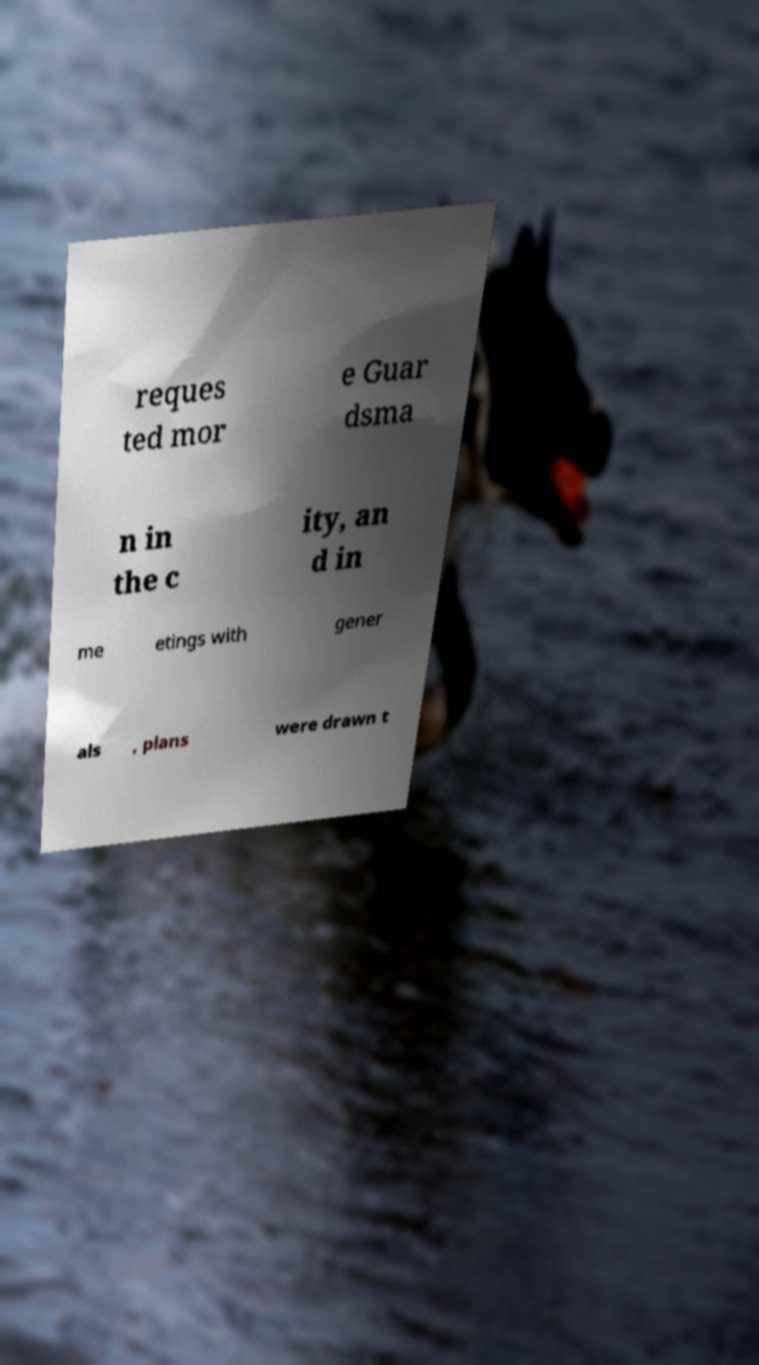Please read and relay the text visible in this image. What does it say? reques ted mor e Guar dsma n in the c ity, an d in me etings with gener als , plans were drawn t 